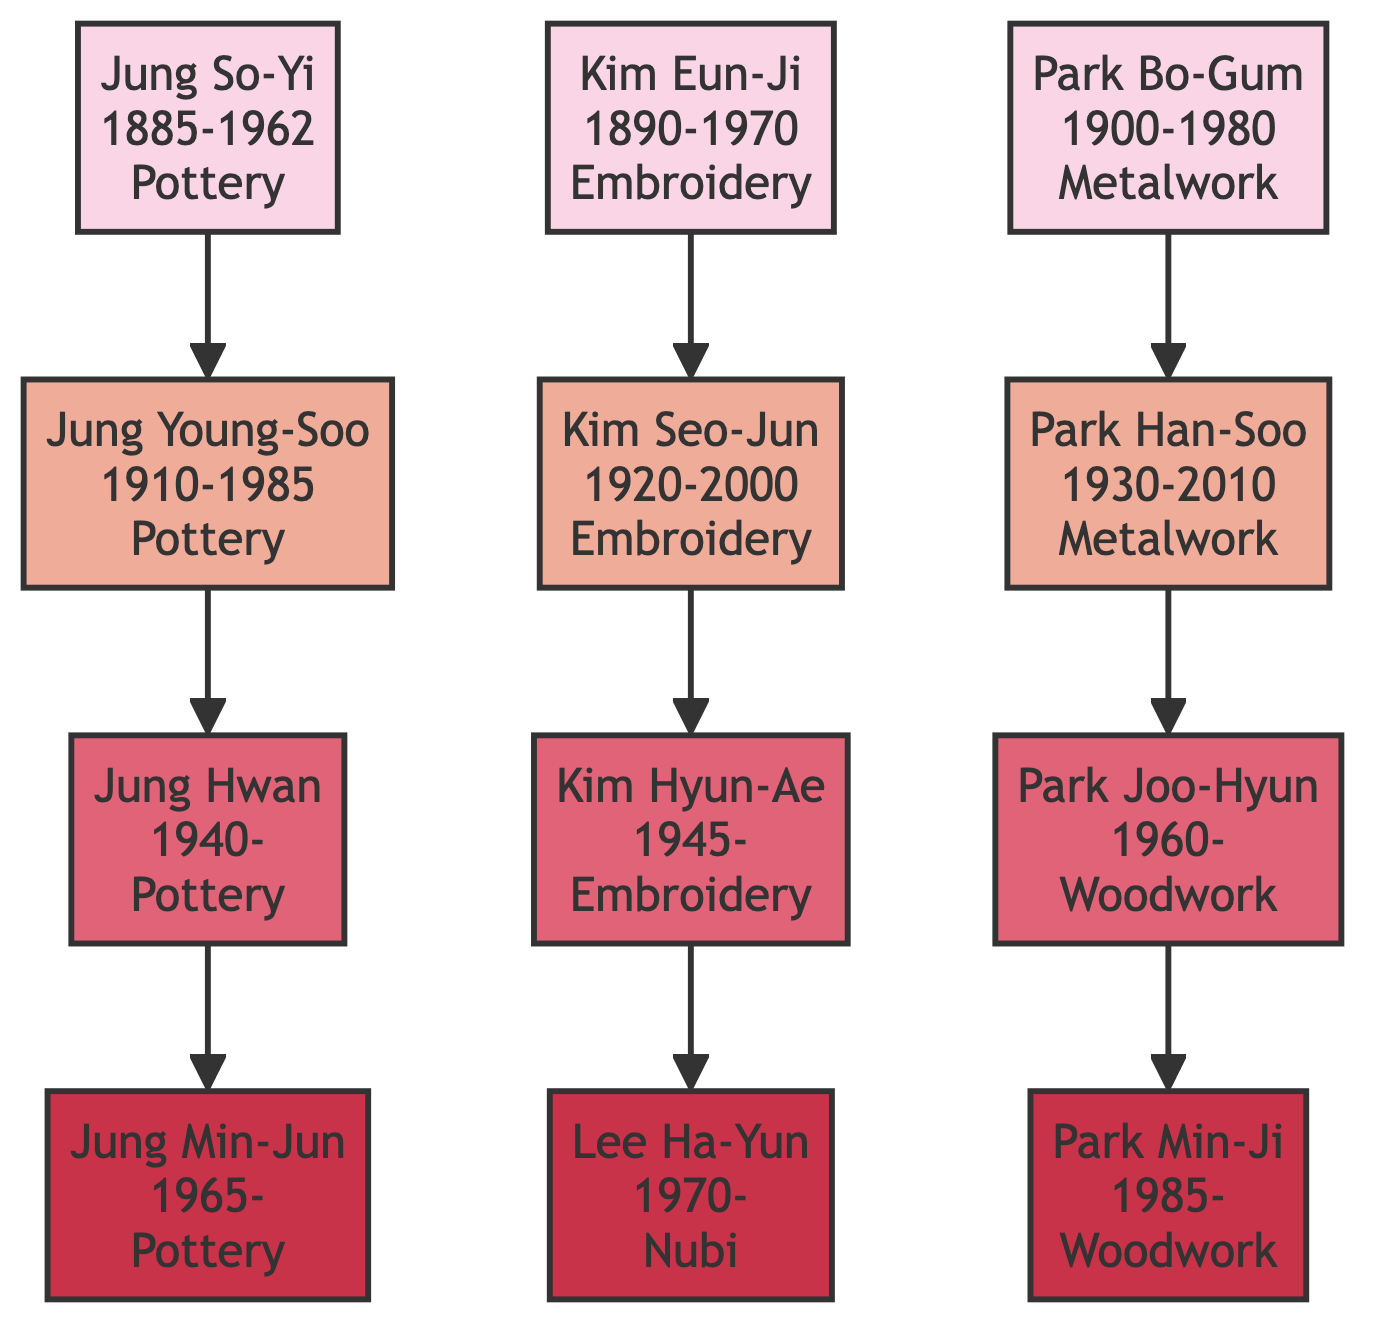What is the craft of Jung So-Yi? Jung So-Yi is listed as a potter in the diagram. This information is directly available under the node for Jung So-Yi.
Answer: Pottery How many generations of craftsmen are shown in this family tree? The family tree illustrates four generations: the ancestors, their children, their grandchildren, and great-grandchildren. This can be counted from the nodes: three levels beneath the ancestors.
Answer: 4 Who created the Crane and Pine Embroidery? The diagram shows that Crane and Pine Embroidery was created by Kim Hyun-Ae, as indicated in her node information under the embroidery craft.
Answer: Kim Hyun-Ae Which craft is associated with Park Joo-Hyun? Park Joo-Hyun is associated with woodwork, as stated in the node that describes his profession.
Answer: Woodwork What notable work did Jung Young-Soo create? The diagram lists the White Porcelain Moon Jar as one of Jung Young-Soo's notable works next to his name in the tree.
Answer: White Porcelain Moon Jar Which generation does Lee Ha-Yun belong to? Lee Ha-Yun is the fourth generation in this family tree, being the child of Kim Hyun-Ae, who is in the third generation.
Answer: 4 How many children did Park Bo-Gum have? Park Bo-Gum had one child, Park Han-Soo, as shown directly in the diagram connecting Park Bo-Gum to Park Han-Soo.
Answer: 1 What are the notable works of Kim Eun-Ji? The notable works of Kim Eun-Ji include Phoenix Embroidery and Royal Wedding Screen, which are specifically listed in her node information.
Answer: Phoenix Embroidery, Royal Wedding Screen Which craft did Jung Min-Jun practice? Jung Min-Jun practiced pottery, as indicated in the respective node outlining his craft.
Answer: Pottery What relationship does Jung Hwan have to Jung So-Yi? Jung Hwan is the grandson of Jung So-Yi, as Jung Hwan is a child of Jung Young-Soo, who is the child of Jung So-Yi.
Answer: Grandson 